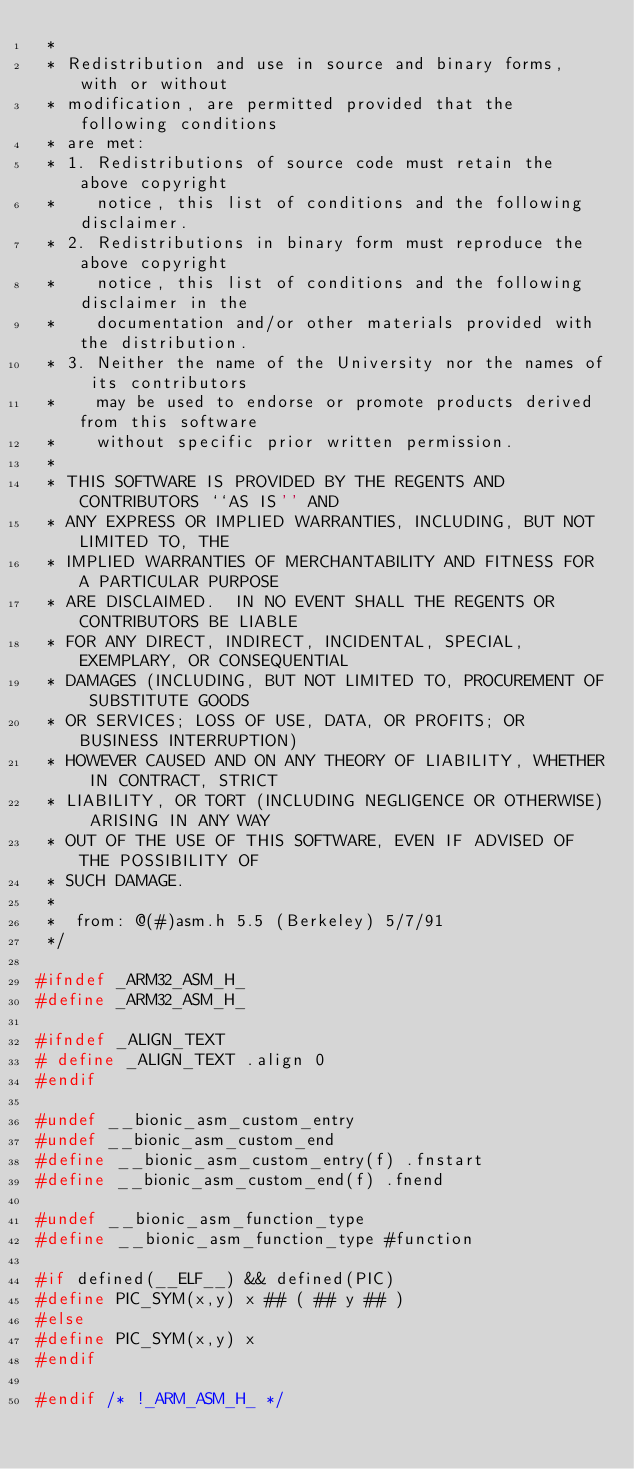Convert code to text. <code><loc_0><loc_0><loc_500><loc_500><_C_> *
 * Redistribution and use in source and binary forms, with or without
 * modification, are permitted provided that the following conditions
 * are met:
 * 1. Redistributions of source code must retain the above copyright
 *    notice, this list of conditions and the following disclaimer.
 * 2. Redistributions in binary form must reproduce the above copyright
 *    notice, this list of conditions and the following disclaimer in the
 *    documentation and/or other materials provided with the distribution.
 * 3. Neither the name of the University nor the names of its contributors
 *    may be used to endorse or promote products derived from this software
 *    without specific prior written permission.
 *
 * THIS SOFTWARE IS PROVIDED BY THE REGENTS AND CONTRIBUTORS ``AS IS'' AND
 * ANY EXPRESS OR IMPLIED WARRANTIES, INCLUDING, BUT NOT LIMITED TO, THE
 * IMPLIED WARRANTIES OF MERCHANTABILITY AND FITNESS FOR A PARTICULAR PURPOSE
 * ARE DISCLAIMED.  IN NO EVENT SHALL THE REGENTS OR CONTRIBUTORS BE LIABLE
 * FOR ANY DIRECT, INDIRECT, INCIDENTAL, SPECIAL, EXEMPLARY, OR CONSEQUENTIAL
 * DAMAGES (INCLUDING, BUT NOT LIMITED TO, PROCUREMENT OF SUBSTITUTE GOODS
 * OR SERVICES; LOSS OF USE, DATA, OR PROFITS; OR BUSINESS INTERRUPTION)
 * HOWEVER CAUSED AND ON ANY THEORY OF LIABILITY, WHETHER IN CONTRACT, STRICT
 * LIABILITY, OR TORT (INCLUDING NEGLIGENCE OR OTHERWISE) ARISING IN ANY WAY
 * OUT OF THE USE OF THIS SOFTWARE, EVEN IF ADVISED OF THE POSSIBILITY OF
 * SUCH DAMAGE.
 *
 *	from: @(#)asm.h	5.5 (Berkeley) 5/7/91
 */

#ifndef _ARM32_ASM_H_
#define _ARM32_ASM_H_

#ifndef _ALIGN_TEXT
# define _ALIGN_TEXT .align 0
#endif

#undef __bionic_asm_custom_entry
#undef __bionic_asm_custom_end
#define __bionic_asm_custom_entry(f) .fnstart
#define __bionic_asm_custom_end(f) .fnend

#undef __bionic_asm_function_type
#define __bionic_asm_function_type #function

#if defined(__ELF__) && defined(PIC)
#define PIC_SYM(x,y) x ## ( ## y ## )
#else
#define PIC_SYM(x,y) x
#endif

#endif /* !_ARM_ASM_H_ */
</code> 